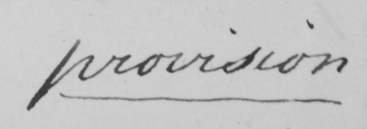Can you tell me what this handwritten text says? provision 